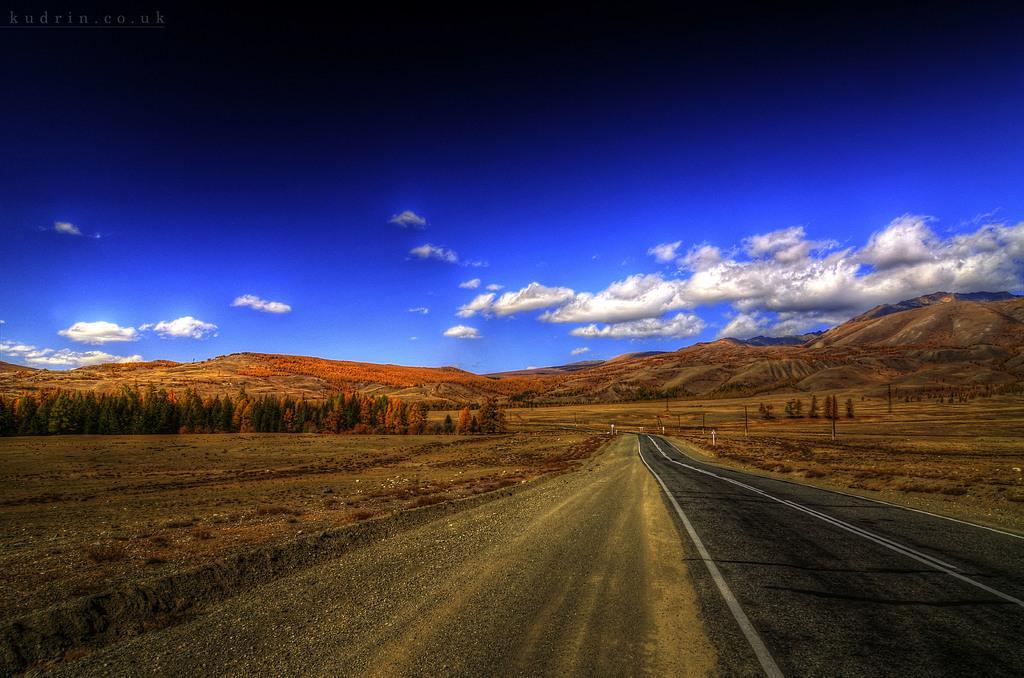Could you give a brief overview of what you see in this image? These are trees, this is is road and a sky. 